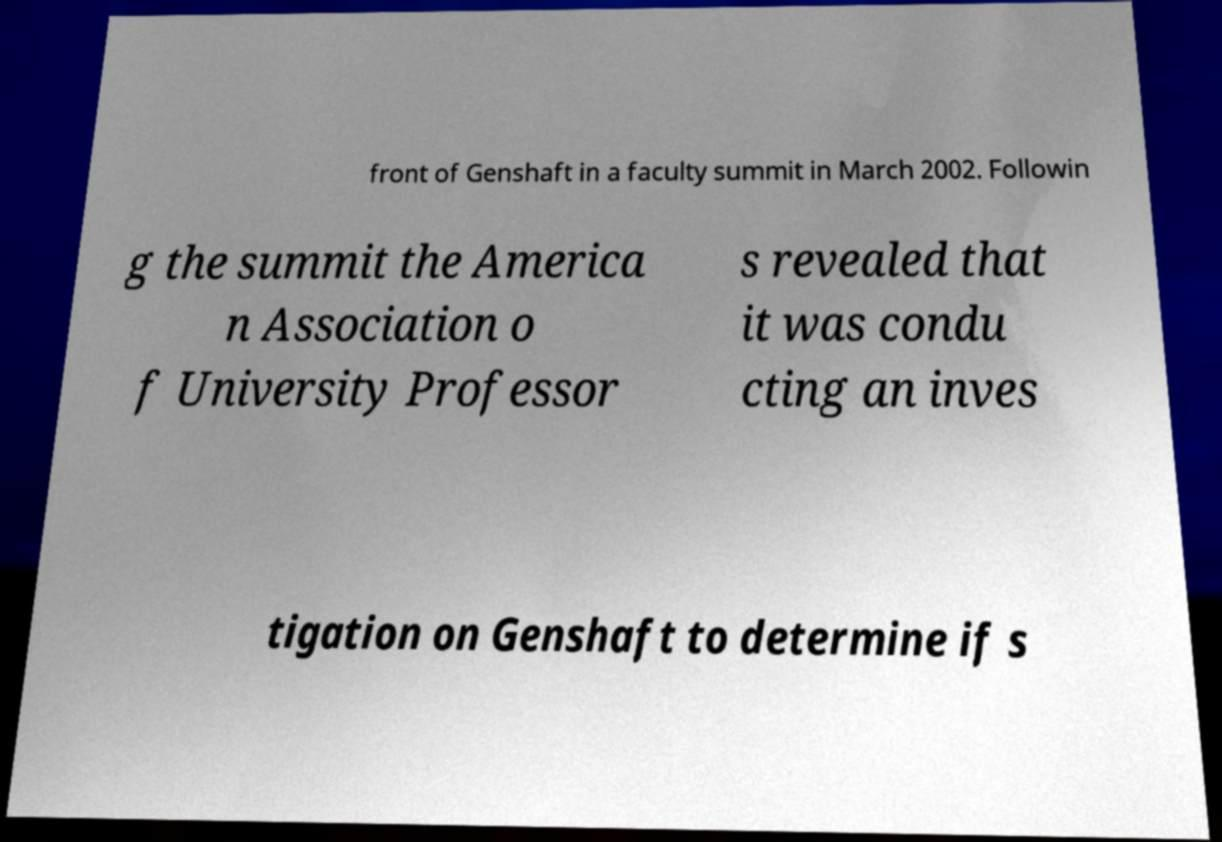Could you assist in decoding the text presented in this image and type it out clearly? front of Genshaft in a faculty summit in March 2002. Followin g the summit the America n Association o f University Professor s revealed that it was condu cting an inves tigation on Genshaft to determine if s 